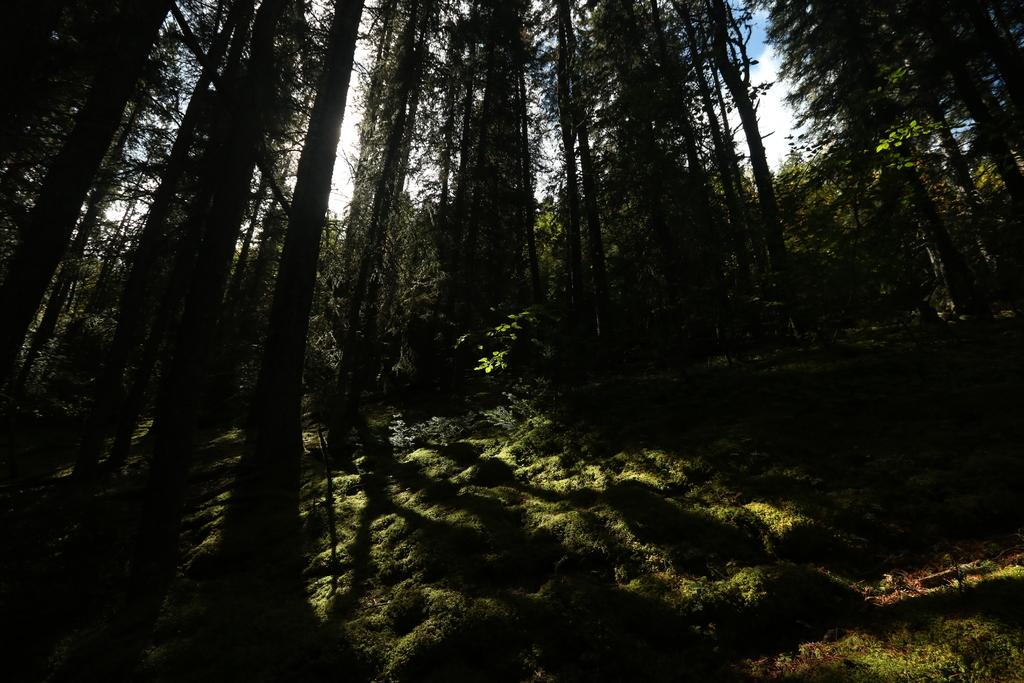What type of vegetation can be seen in the image? There are trees in the image. What is on the ground in the image? There is grass on the ground in the image. What can be seen in the background of the image? The sky is visible in the background of the image. What is present in the sky? Clouds are present in the sky. How many cents are visible on the tree in the image? There are no cents present in the image; it features trees, grass, and clouds. What type of crayon can be seen being used to draw on the grass in the image? There is no crayon present in the image, and no one is drawing on the grass. 